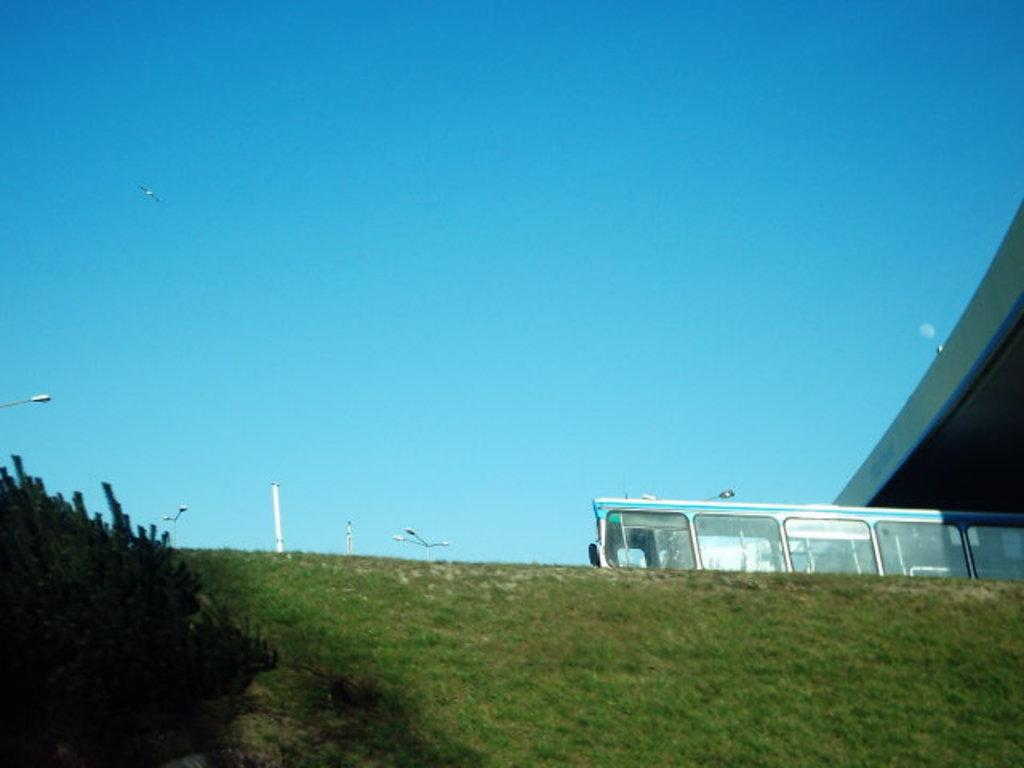What type of surface is on the ground in the image? There is grass on the ground in the image. What can be seen on the left side of the image? There are plants on the left side of the image. What type of object is present in the image? There is a vehicle in the image. What is visible in the background of the image? The sky is visible in the background of the image. What color is the sky in the image? The sky is blue in color. What type of suit is the moon wearing in the image? There is no moon present in the image, and therefore no suit can be observed. What feeling does the grass evoke in the image? The image does not convey feelings or emotions, so it is not possible to determine the feeling evoked by the grass. 